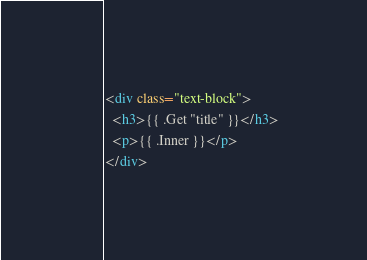<code> <loc_0><loc_0><loc_500><loc_500><_HTML_><div class="text-block">
  <h3>{{ .Get "title" }}</h3>
  <p>{{ .Inner }}</p>
</div>
</code> 